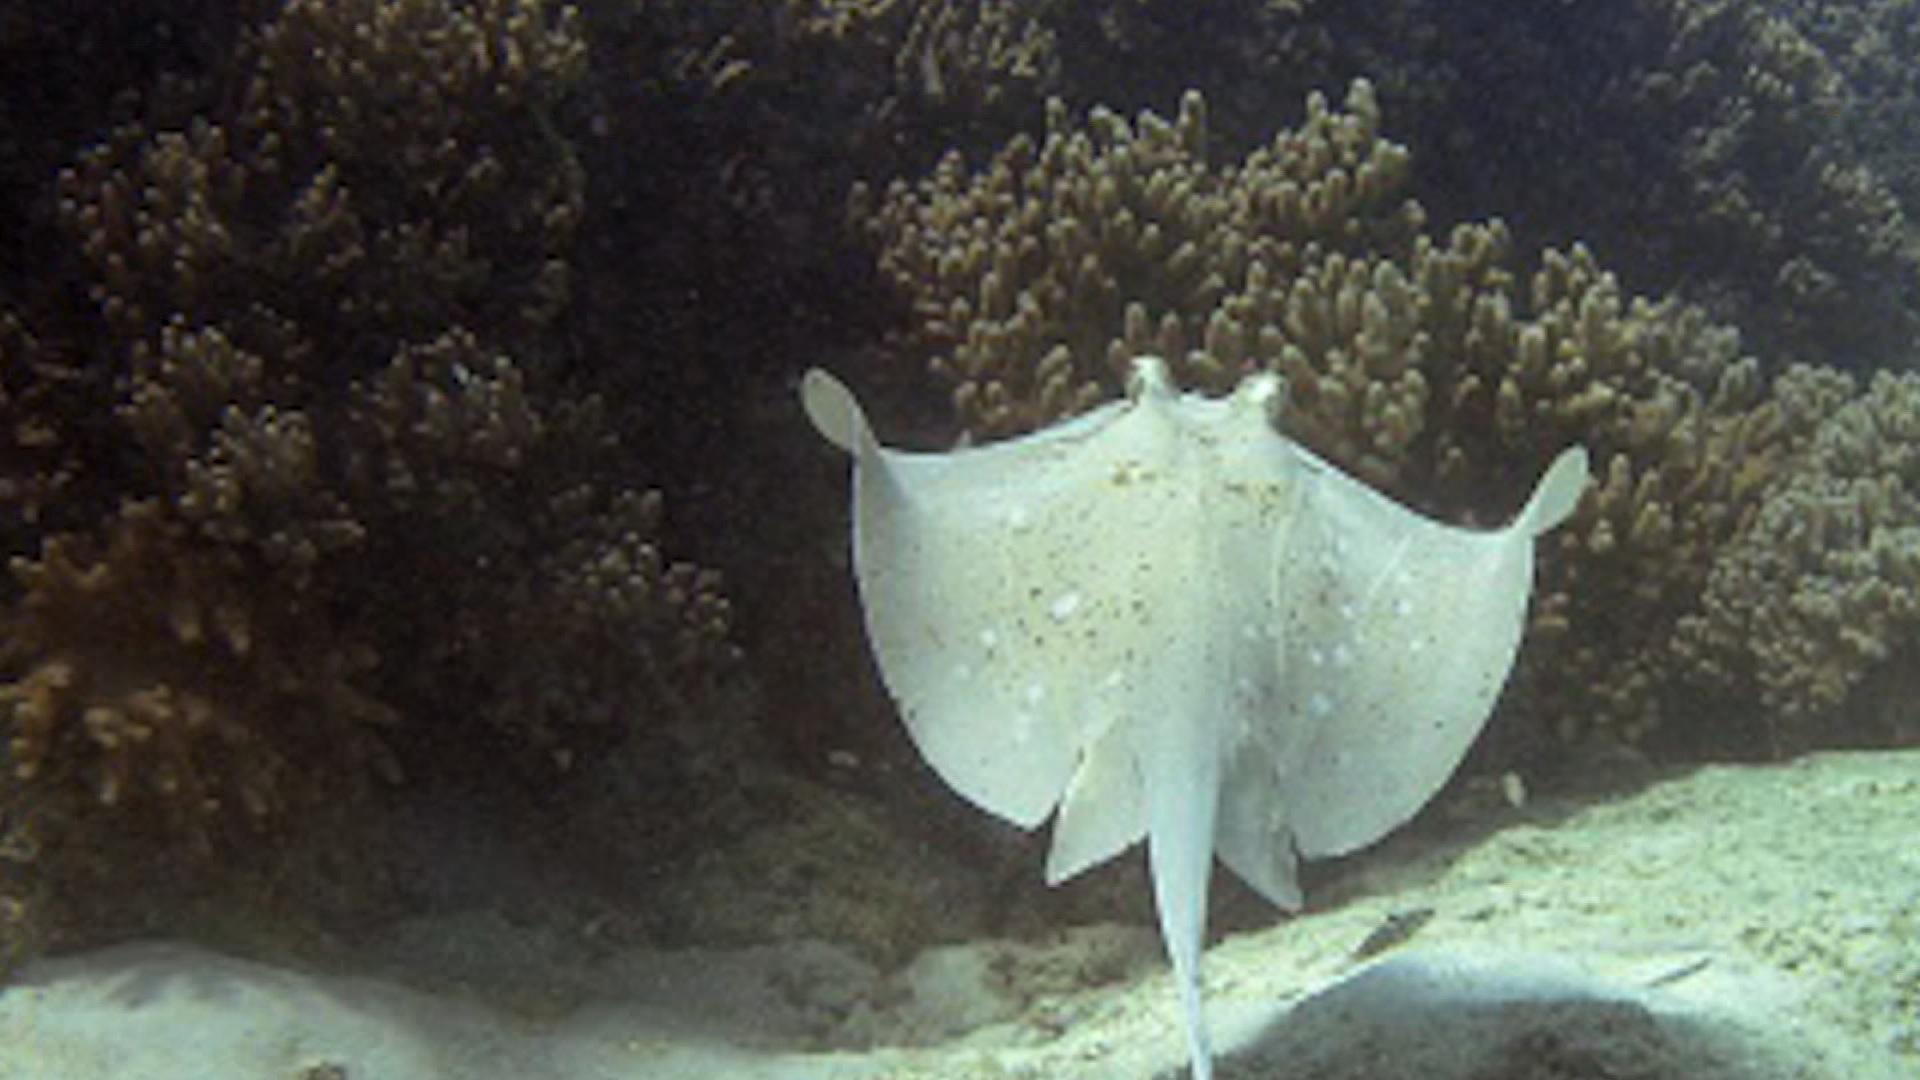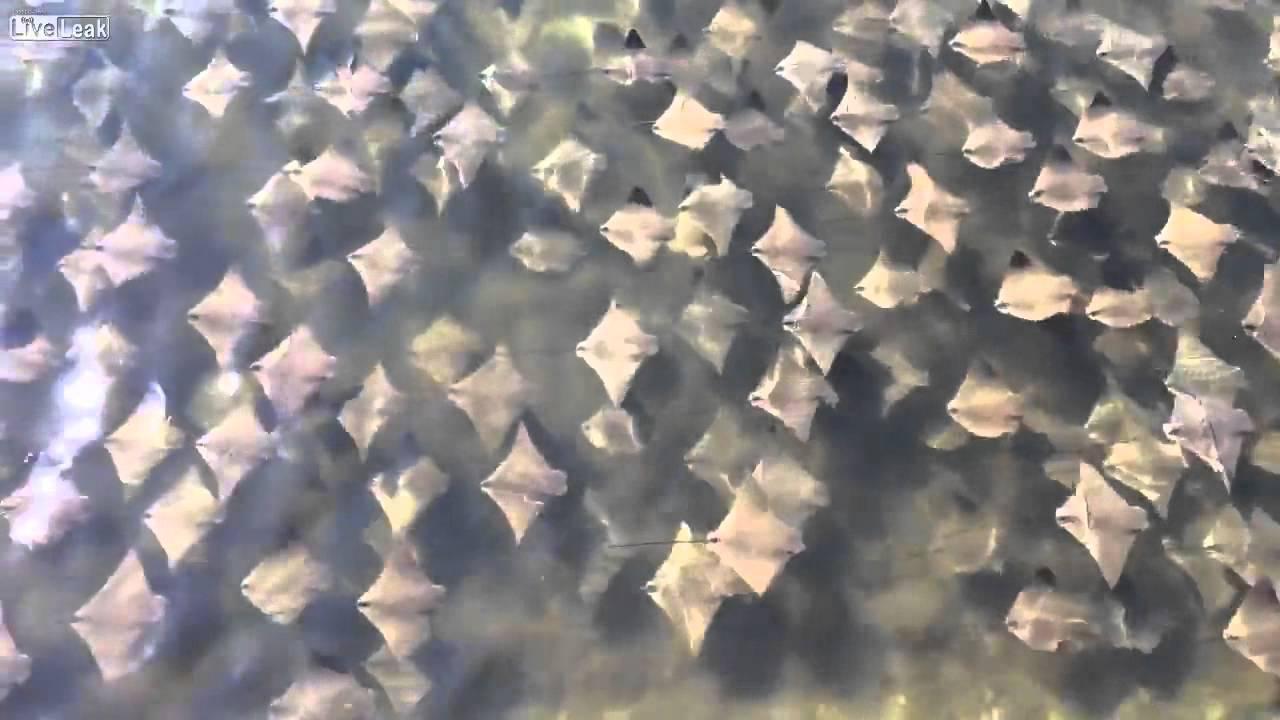The first image is the image on the left, the second image is the image on the right. Assess this claim about the two images: "A single ray is shown in one of the images.". Correct or not? Answer yes or no. Yes. 